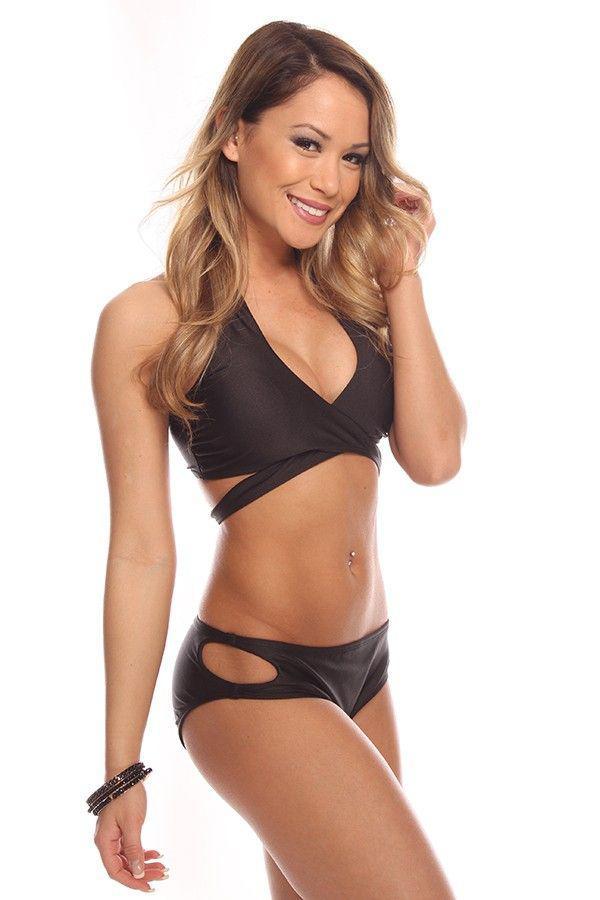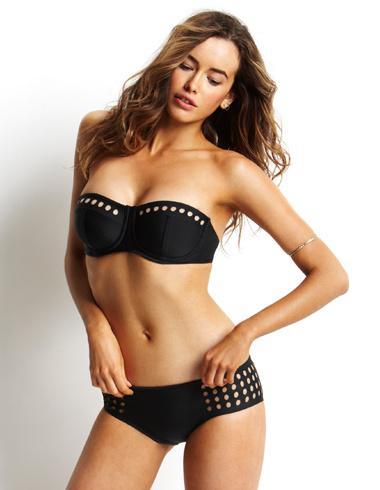The first image is the image on the left, the second image is the image on the right. Examine the images to the left and right. Is the description "Both bottoms are solid black." accurate? Answer yes or no. Yes. The first image is the image on the left, the second image is the image on the right. Given the left and right images, does the statement "Each model is wearing a black bikini top and bottom." hold true? Answer yes or no. Yes. 